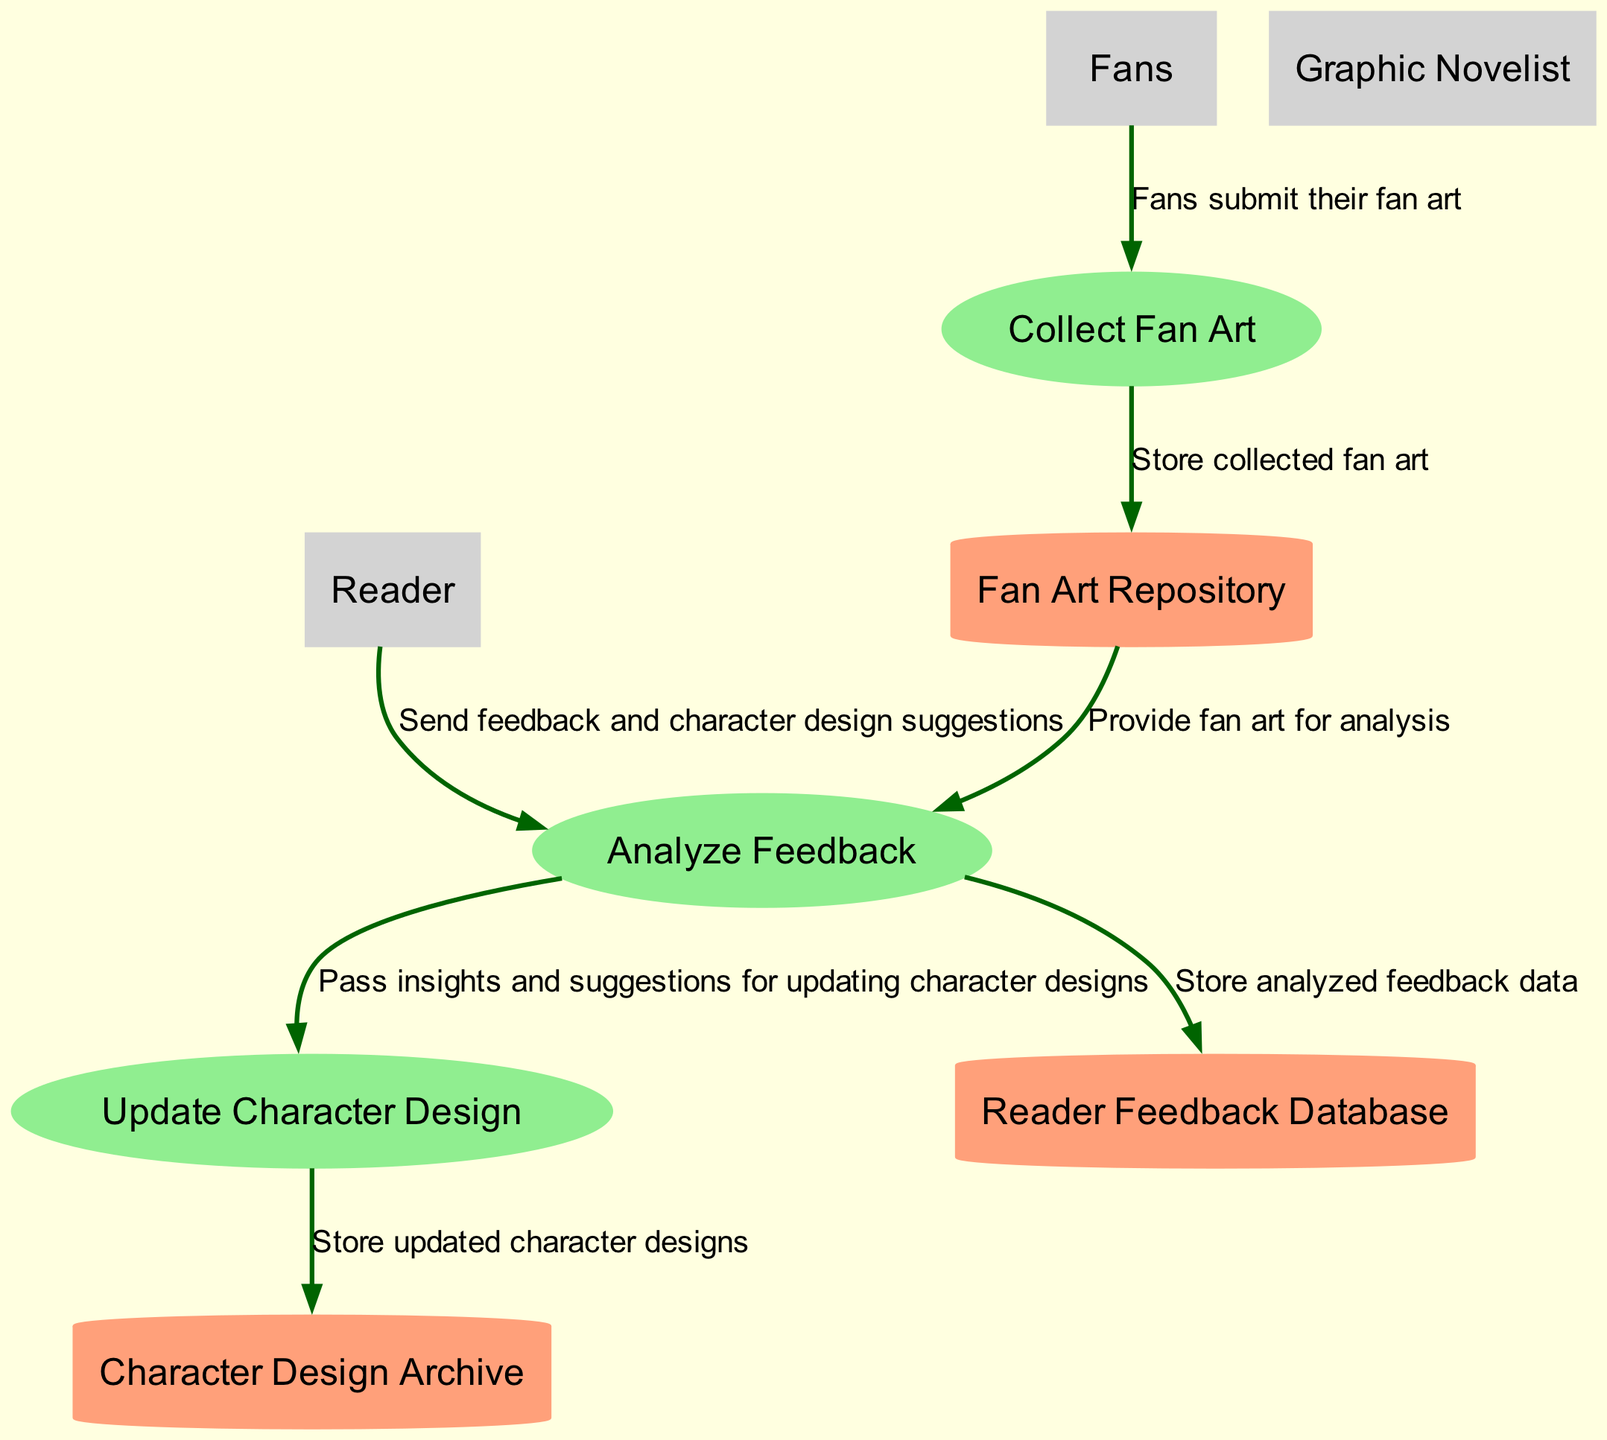What is the name of the first process in the diagram? The first process is identified as "Collect Fan Art," which can be found at the top of the diagram.
Answer: Collect Fan Art How many data stores are there in the diagram? The diagram lists three data stores: "Fan Art Repository," "Reader Feedback Database," and "Character Design Archive." Counting these gives us a total of three data stores.
Answer: 3 Who collects the feedback from readers? The process responsible for collecting feedback is called "Analyze Feedback," which indicates that it handles the suggestions and comments from readers.
Answer: Analyze Feedback What type of entity submits fan art? The diagram shows that "Fans" are the external entities submitting fan art to the process named "Collect Fan Art."
Answer: Fans Which process exists between "Analyze Feedback" and "Update Character Design"? The direct relationship indicates that "Analyze Feedback" sends insights and suggestions to "Update Character Design" for modifying the character designs.
Answer: Update Character Design Where is the updated character design stored? The storage location for the updated character design is referred to as "Character Design Archive," which is indicated in the final flow of the diagram.
Answer: Character Design Archive What is the starting point for fan art submissions in the process? The flow begins with "Fans," who submit their fan art to the "Collect Fan Art" process, indicating the origin of this input.
Answer: Fans How does the fan art influence character design? Fan art influences character design through the flow from "Analyze Feedback," where insights derived from both the fan art and reader suggestions are passed to "Update Character Design."
Answer: Update Character Design 